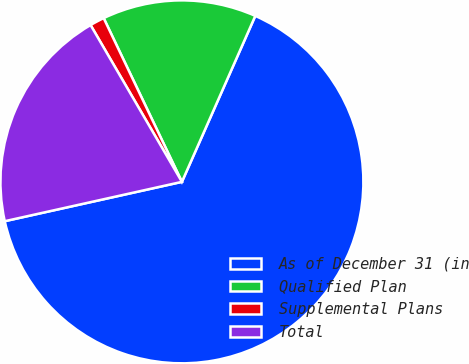Convert chart to OTSL. <chart><loc_0><loc_0><loc_500><loc_500><pie_chart><fcel>As of December 31 (in<fcel>Qualified Plan<fcel>Supplemental Plans<fcel>Total<nl><fcel>64.89%<fcel>13.72%<fcel>1.3%<fcel>20.08%<nl></chart> 